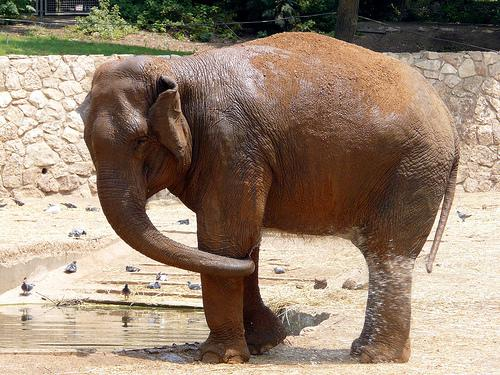Question: what kind of animal is in the picture?
Choices:
A. An elephant.
B. Squirrel.
C. Donkey.
D. Dog.
Answer with the letter. Answer: A Question: how many elephants are in the picture?
Choices:
A. Two.
B. One.
C. Four.
D. Three.
Answer with the letter. Answer: B Question: what color is the grass?
Choices:
A. Brown.
B. Blue.
C. Green.
D. Yellow.
Answer with the letter. Answer: C Question: what color is the elephant?
Choices:
A. Gray.
B. Brown.
C. Black.
D. Tan.
Answer with the letter. Answer: B Question: what color is the rock wall?
Choices:
A. Slate gray.
B. Beige.
C. Brown.
D. White.
Answer with the letter. Answer: B Question: when was the picture taken?
Choices:
A. During the day.
B. Night.
C. In the future.
D. Midnight.
Answer with the letter. Answer: A 